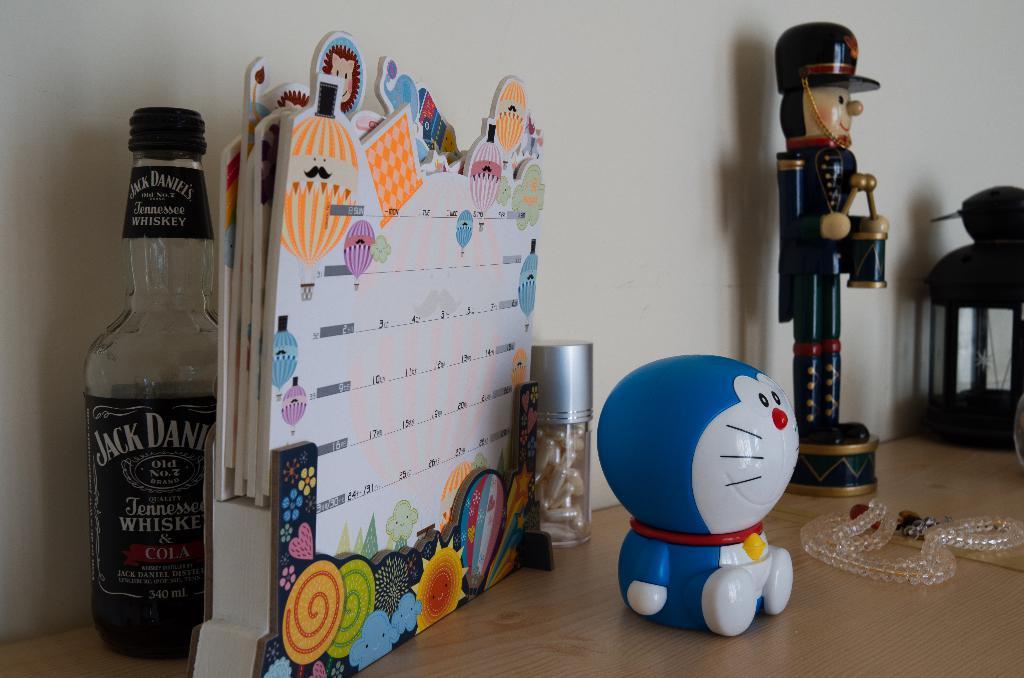How would you summarize this image in a sentence or two? In the image we can see there is a table on which there is a cat toy and a calendar and in a bottle there are capsules and behind the calendar there is a wine bottle. 